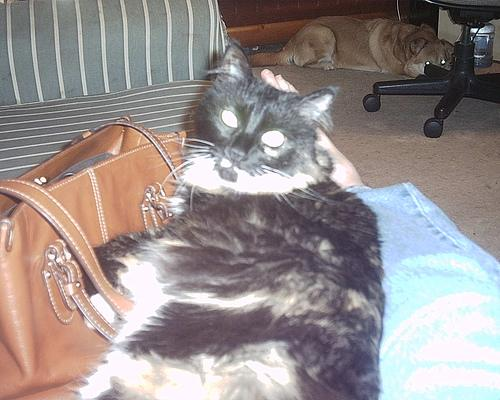What human body part does the cat lean back on?

Choices:
A) arm
B) neck
C) leg
D) head leg 